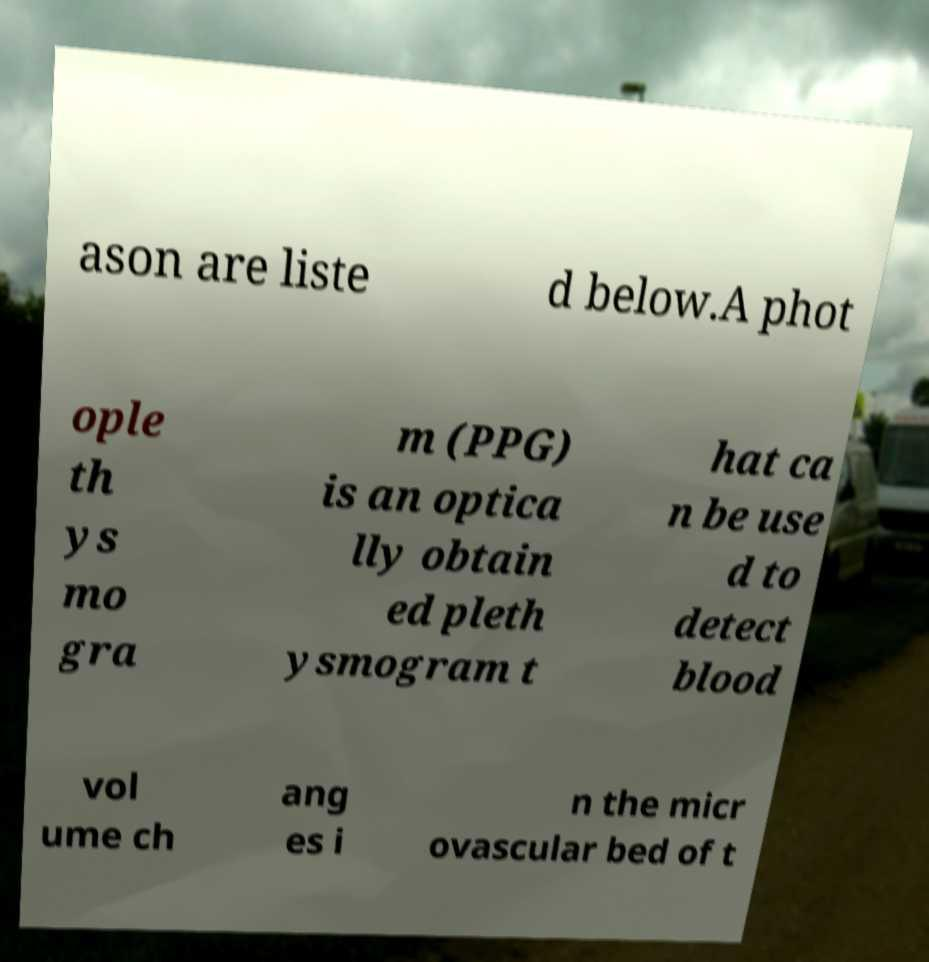Could you assist in decoding the text presented in this image and type it out clearly? ason are liste d below.A phot ople th ys mo gra m (PPG) is an optica lly obtain ed pleth ysmogram t hat ca n be use d to detect blood vol ume ch ang es i n the micr ovascular bed of t 